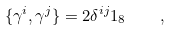Convert formula to latex. <formula><loc_0><loc_0><loc_500><loc_500>\{ \gamma ^ { i } , \gamma ^ { j } \} = 2 \delta ^ { i j } 1 _ { 8 } \quad ,</formula> 